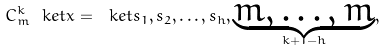<formula> <loc_0><loc_0><loc_500><loc_500>C ^ { k } _ { m } \ k e t { x } = \ k e t { s _ { 1 } , s _ { 2 } , \dots , s _ { h } , \underbrace { m , \dots , m } _ { k + 1 - h } } ,</formula> 